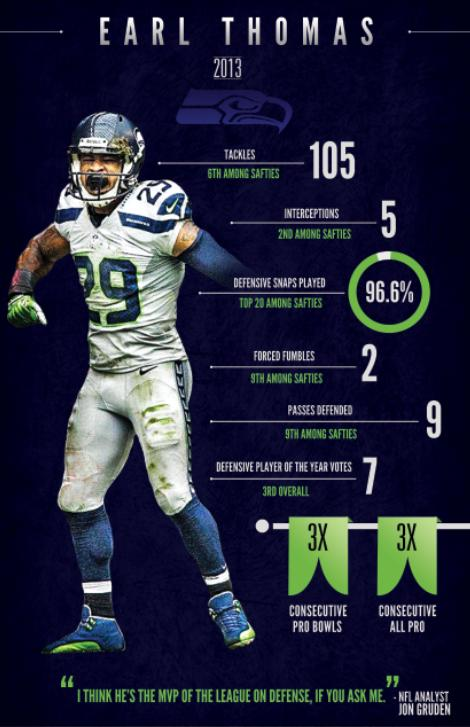Give some essential details in this illustration. Earl Thomas plays for the Seattle Seahawks. 